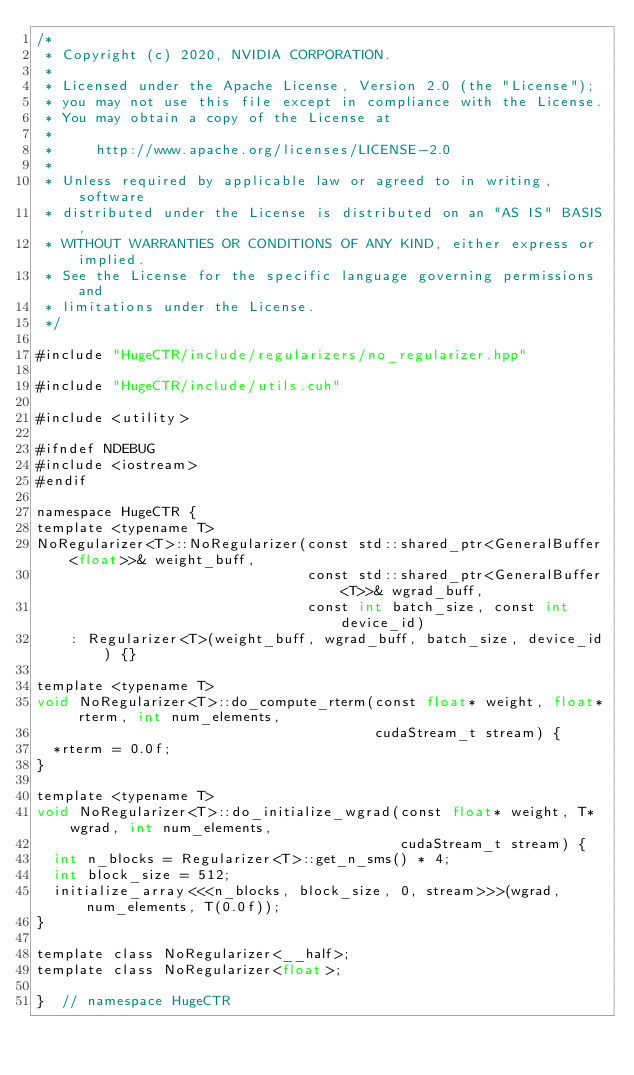Convert code to text. <code><loc_0><loc_0><loc_500><loc_500><_Cuda_>/*
 * Copyright (c) 2020, NVIDIA CORPORATION.
 *
 * Licensed under the Apache License, Version 2.0 (the "License");
 * you may not use this file except in compliance with the License.
 * You may obtain a copy of the License at
 *
 *     http://www.apache.org/licenses/LICENSE-2.0
 *
 * Unless required by applicable law or agreed to in writing, software
 * distributed under the License is distributed on an "AS IS" BASIS,
 * WITHOUT WARRANTIES OR CONDITIONS OF ANY KIND, either express or implied.
 * See the License for the specific language governing permissions and
 * limitations under the License.
 */

#include "HugeCTR/include/regularizers/no_regularizer.hpp"

#include "HugeCTR/include/utils.cuh"

#include <utility>

#ifndef NDEBUG
#include <iostream>
#endif

namespace HugeCTR {
template <typename T>
NoRegularizer<T>::NoRegularizer(const std::shared_ptr<GeneralBuffer<float>>& weight_buff,
                                const std::shared_ptr<GeneralBuffer<T>>& wgrad_buff,
                                const int batch_size, const int device_id)
    : Regularizer<T>(weight_buff, wgrad_buff, batch_size, device_id) {}

template <typename T>
void NoRegularizer<T>::do_compute_rterm(const float* weight, float* rterm, int num_elements,
                                        cudaStream_t stream) {
  *rterm = 0.0f;
}

template <typename T>
void NoRegularizer<T>::do_initialize_wgrad(const float* weight, T* wgrad, int num_elements,
                                           cudaStream_t stream) {
  int n_blocks = Regularizer<T>::get_n_sms() * 4;
  int block_size = 512;
  initialize_array<<<n_blocks, block_size, 0, stream>>>(wgrad, num_elements, T(0.0f));
}

template class NoRegularizer<__half>;
template class NoRegularizer<float>;

}  // namespace HugeCTR
</code> 